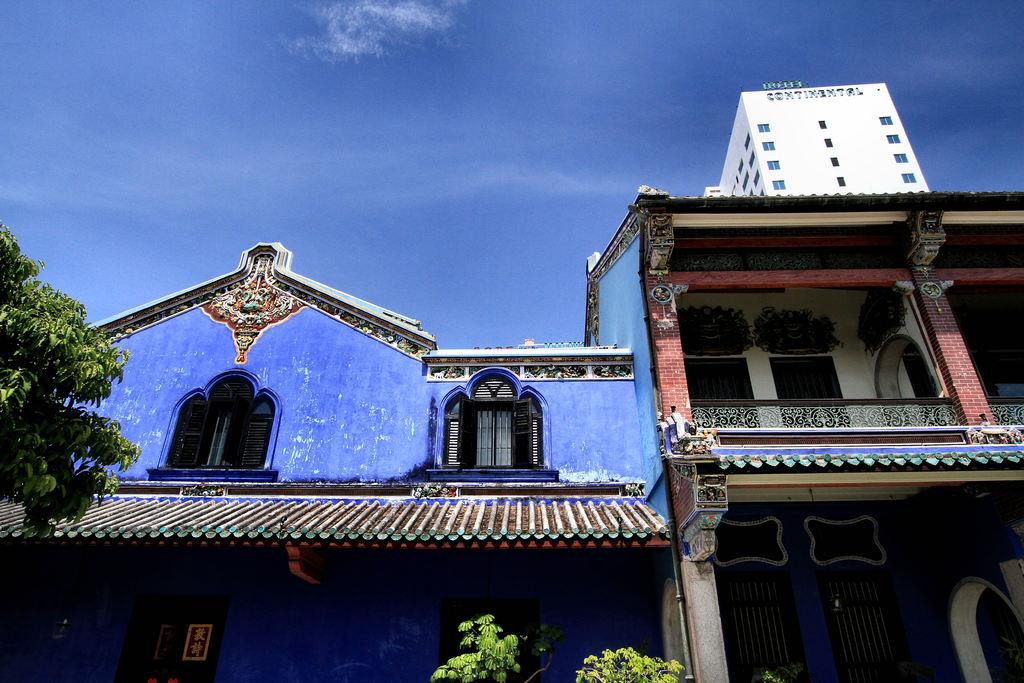What type of structures can be seen in the image? There are buildings in the image. What type of vegetation is present in the image? There is a tree and plants in the image. What part of the natural environment is visible in the image? The sky is visible in the image. What color is the bulb that is being rubbed in the image? There is no bulb or rubbing action present in the image. What type of paint is being used to decorate the buildings in the image? There is no paint or decoration visible on the buildings in the image. 